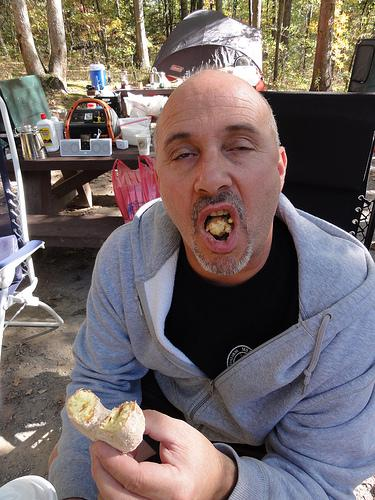Question: why is his mouth open?
Choices:
A. To yawn.
B. To drink water.
C. To show food.
D. To express surprise.
Answer with the letter. Answer: C Question: how many men?
Choices:
A. Zero.
B. Two.
C. Three.
D. One.
Answer with the letter. Answer: D Question: what is he eating?
Choices:
A. Bread.
B. Donut.
C. Chicken.
D. Sandwich.
Answer with the letter. Answer: B Question: what is grey?
Choices:
A. Shoes.
B. Pants.
C. Tie.
D. Jacket.
Answer with the letter. Answer: D Question: what is green?
Choices:
A. Traffic light.
B. Bushes.
C. Trees.
D. Grass.
Answer with the letter. Answer: C 